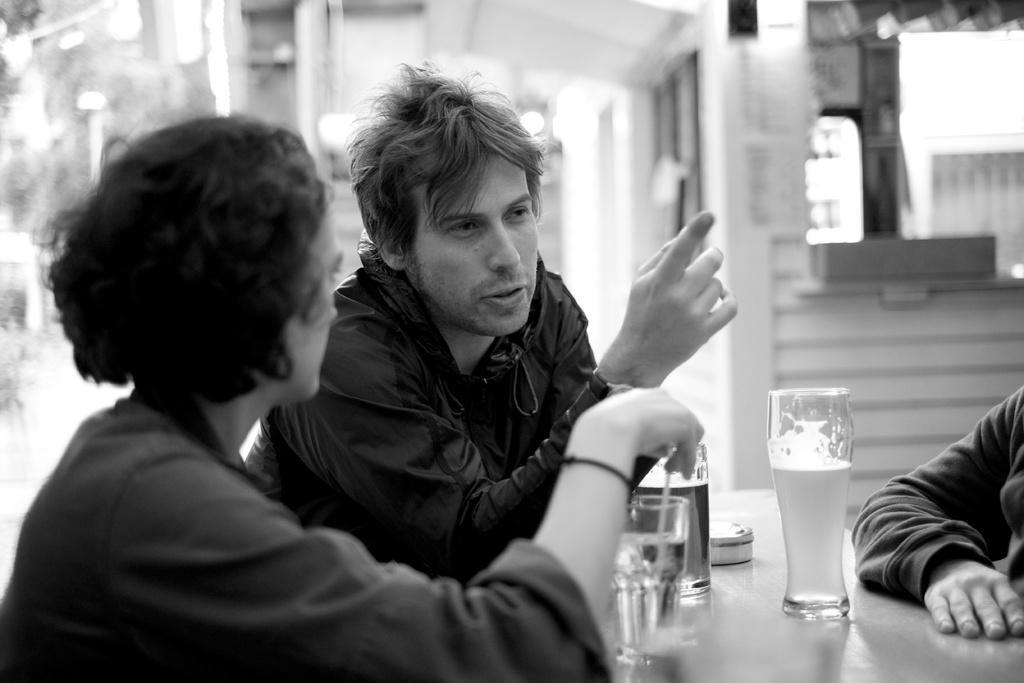Describe this image in one or two sentences. In the image there are three people sitting in front of a table, on table we can see a glass,straw and a glass with some drink. In background there is a building,window and a wall which is in white color. 